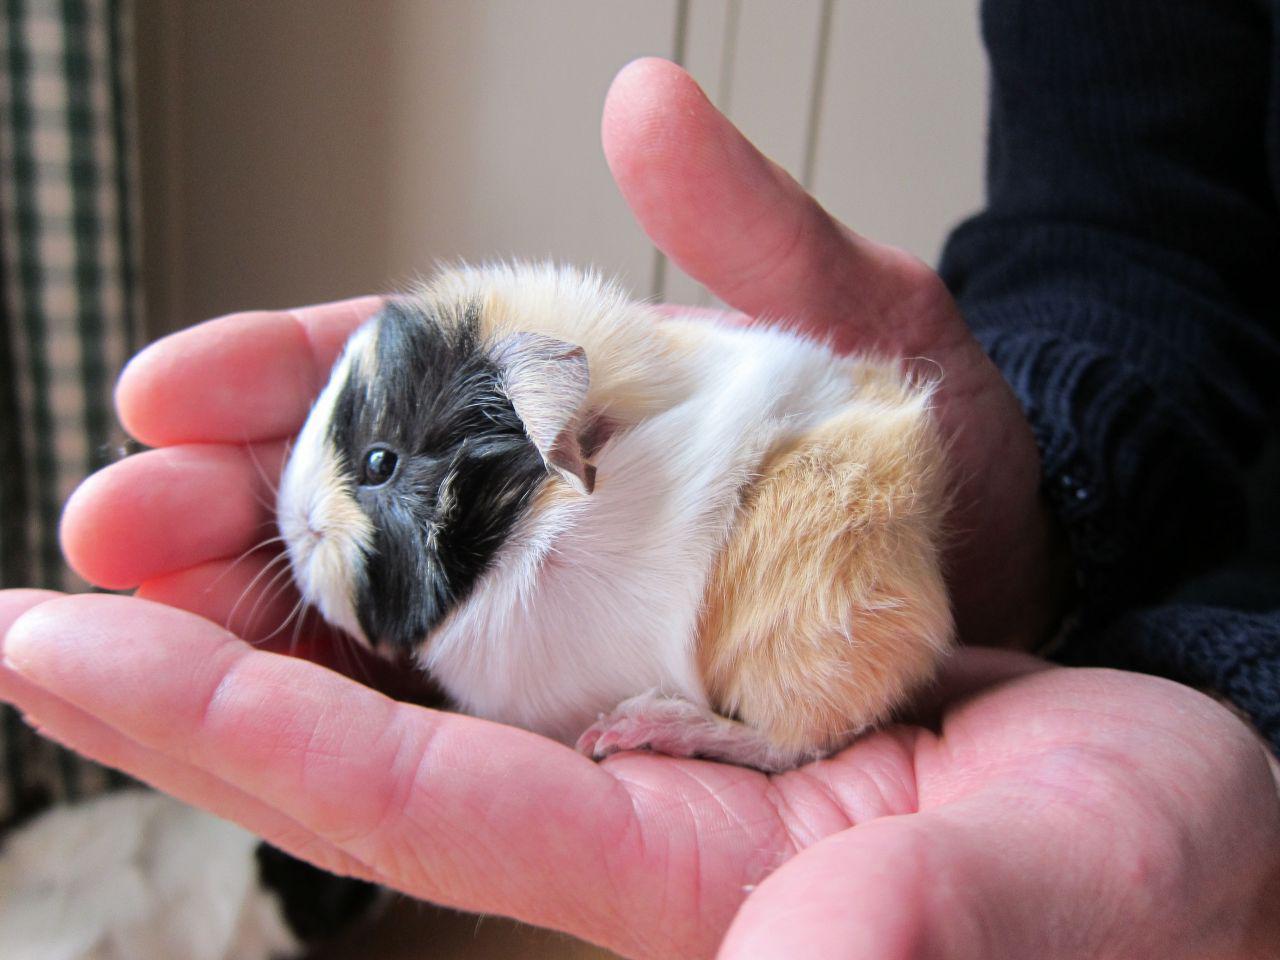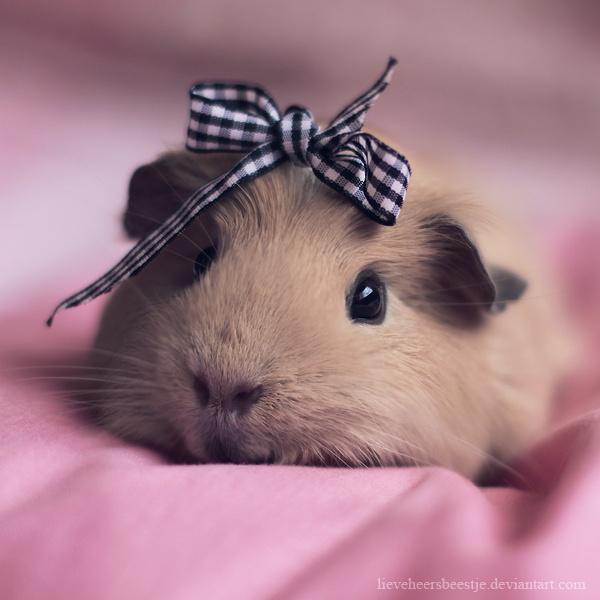The first image is the image on the left, the second image is the image on the right. Evaluate the accuracy of this statement regarding the images: "Left image shows a pair of hands holding a tri-colored hamster.". Is it true? Answer yes or no. Yes. 